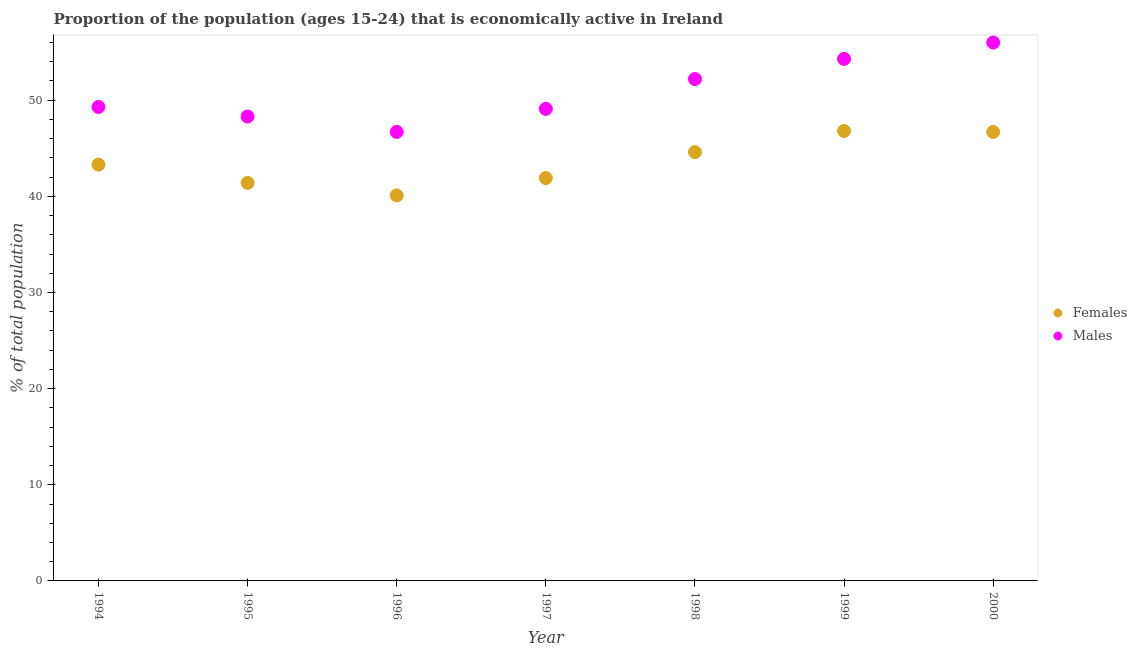How many different coloured dotlines are there?
Offer a very short reply. 2. What is the percentage of economically active female population in 2000?
Make the answer very short. 46.7. Across all years, what is the maximum percentage of economically active female population?
Offer a very short reply. 46.8. Across all years, what is the minimum percentage of economically active female population?
Offer a very short reply. 40.1. What is the total percentage of economically active female population in the graph?
Give a very brief answer. 304.8. What is the difference between the percentage of economically active male population in 1998 and the percentage of economically active female population in 1995?
Ensure brevity in your answer.  10.8. What is the average percentage of economically active male population per year?
Keep it short and to the point. 50.84. In the year 1995, what is the difference between the percentage of economically active female population and percentage of economically active male population?
Your answer should be very brief. -6.9. What is the ratio of the percentage of economically active male population in 1994 to that in 1996?
Your answer should be very brief. 1.06. What is the difference between the highest and the second highest percentage of economically active female population?
Ensure brevity in your answer.  0.1. What is the difference between the highest and the lowest percentage of economically active male population?
Give a very brief answer. 9.3. Does the percentage of economically active male population monotonically increase over the years?
Your answer should be compact. No. Is the percentage of economically active male population strictly greater than the percentage of economically active female population over the years?
Provide a short and direct response. Yes. How many dotlines are there?
Provide a succinct answer. 2. Does the graph contain any zero values?
Provide a succinct answer. No. Does the graph contain grids?
Keep it short and to the point. No. Where does the legend appear in the graph?
Keep it short and to the point. Center right. How many legend labels are there?
Provide a short and direct response. 2. How are the legend labels stacked?
Offer a very short reply. Vertical. What is the title of the graph?
Your response must be concise. Proportion of the population (ages 15-24) that is economically active in Ireland. Does "Domestic Liabilities" appear as one of the legend labels in the graph?
Keep it short and to the point. No. What is the label or title of the Y-axis?
Provide a succinct answer. % of total population. What is the % of total population in Females in 1994?
Keep it short and to the point. 43.3. What is the % of total population in Males in 1994?
Ensure brevity in your answer.  49.3. What is the % of total population in Females in 1995?
Offer a terse response. 41.4. What is the % of total population in Males in 1995?
Offer a very short reply. 48.3. What is the % of total population of Females in 1996?
Your response must be concise. 40.1. What is the % of total population in Males in 1996?
Your response must be concise. 46.7. What is the % of total population in Females in 1997?
Make the answer very short. 41.9. What is the % of total population of Males in 1997?
Ensure brevity in your answer.  49.1. What is the % of total population of Females in 1998?
Your response must be concise. 44.6. What is the % of total population of Males in 1998?
Ensure brevity in your answer.  52.2. What is the % of total population of Females in 1999?
Offer a very short reply. 46.8. What is the % of total population in Males in 1999?
Your answer should be compact. 54.3. What is the % of total population of Females in 2000?
Offer a very short reply. 46.7. What is the % of total population in Males in 2000?
Your answer should be compact. 56. Across all years, what is the maximum % of total population in Females?
Your response must be concise. 46.8. Across all years, what is the maximum % of total population of Males?
Make the answer very short. 56. Across all years, what is the minimum % of total population of Females?
Give a very brief answer. 40.1. Across all years, what is the minimum % of total population of Males?
Offer a terse response. 46.7. What is the total % of total population in Females in the graph?
Offer a terse response. 304.8. What is the total % of total population in Males in the graph?
Offer a very short reply. 355.9. What is the difference between the % of total population in Females in 1994 and that in 1996?
Offer a terse response. 3.2. What is the difference between the % of total population in Males in 1994 and that in 1996?
Make the answer very short. 2.6. What is the difference between the % of total population of Females in 1994 and that in 1999?
Keep it short and to the point. -3.5. What is the difference between the % of total population in Males in 1994 and that in 1999?
Your answer should be compact. -5. What is the difference between the % of total population in Females in 1994 and that in 2000?
Offer a terse response. -3.4. What is the difference between the % of total population in Females in 1995 and that in 1997?
Offer a terse response. -0.5. What is the difference between the % of total population of Males in 1995 and that in 1997?
Your answer should be very brief. -0.8. What is the difference between the % of total population in Females in 1995 and that in 1998?
Your answer should be compact. -3.2. What is the difference between the % of total population of Males in 1995 and that in 1998?
Make the answer very short. -3.9. What is the difference between the % of total population in Females in 1996 and that in 1999?
Your answer should be very brief. -6.7. What is the difference between the % of total population in Males in 1996 and that in 1999?
Make the answer very short. -7.6. What is the difference between the % of total population in Males in 1996 and that in 2000?
Your answer should be very brief. -9.3. What is the difference between the % of total population of Females in 1997 and that in 1999?
Give a very brief answer. -4.9. What is the difference between the % of total population in Females in 1997 and that in 2000?
Make the answer very short. -4.8. What is the difference between the % of total population in Males in 1997 and that in 2000?
Your response must be concise. -6.9. What is the difference between the % of total population of Males in 1998 and that in 2000?
Offer a very short reply. -3.8. What is the difference between the % of total population in Females in 1994 and the % of total population in Males in 1997?
Your answer should be very brief. -5.8. What is the difference between the % of total population in Females in 1994 and the % of total population in Males in 1998?
Offer a very short reply. -8.9. What is the difference between the % of total population of Females in 1995 and the % of total population of Males in 1998?
Your answer should be very brief. -10.8. What is the difference between the % of total population in Females in 1995 and the % of total population in Males in 1999?
Offer a terse response. -12.9. What is the difference between the % of total population of Females in 1995 and the % of total population of Males in 2000?
Ensure brevity in your answer.  -14.6. What is the difference between the % of total population of Females in 1996 and the % of total population of Males in 1999?
Provide a short and direct response. -14.2. What is the difference between the % of total population of Females in 1996 and the % of total population of Males in 2000?
Give a very brief answer. -15.9. What is the difference between the % of total population of Females in 1997 and the % of total population of Males in 2000?
Your answer should be very brief. -14.1. What is the difference between the % of total population in Females in 1998 and the % of total population in Males in 2000?
Give a very brief answer. -11.4. What is the difference between the % of total population of Females in 1999 and the % of total population of Males in 2000?
Offer a very short reply. -9.2. What is the average % of total population in Females per year?
Keep it short and to the point. 43.54. What is the average % of total population of Males per year?
Your answer should be very brief. 50.84. In the year 1996, what is the difference between the % of total population of Females and % of total population of Males?
Keep it short and to the point. -6.6. In the year 1997, what is the difference between the % of total population in Females and % of total population in Males?
Provide a succinct answer. -7.2. In the year 1998, what is the difference between the % of total population in Females and % of total population in Males?
Keep it short and to the point. -7.6. In the year 1999, what is the difference between the % of total population of Females and % of total population of Males?
Make the answer very short. -7.5. In the year 2000, what is the difference between the % of total population of Females and % of total population of Males?
Your answer should be compact. -9.3. What is the ratio of the % of total population in Females in 1994 to that in 1995?
Offer a terse response. 1.05. What is the ratio of the % of total population in Males in 1994 to that in 1995?
Ensure brevity in your answer.  1.02. What is the ratio of the % of total population of Females in 1994 to that in 1996?
Keep it short and to the point. 1.08. What is the ratio of the % of total population of Males in 1994 to that in 1996?
Your answer should be compact. 1.06. What is the ratio of the % of total population in Females in 1994 to that in 1997?
Provide a succinct answer. 1.03. What is the ratio of the % of total population of Females in 1994 to that in 1998?
Your answer should be compact. 0.97. What is the ratio of the % of total population of Males in 1994 to that in 1998?
Offer a terse response. 0.94. What is the ratio of the % of total population in Females in 1994 to that in 1999?
Offer a very short reply. 0.93. What is the ratio of the % of total population in Males in 1994 to that in 1999?
Give a very brief answer. 0.91. What is the ratio of the % of total population of Females in 1994 to that in 2000?
Make the answer very short. 0.93. What is the ratio of the % of total population in Males in 1994 to that in 2000?
Offer a very short reply. 0.88. What is the ratio of the % of total population of Females in 1995 to that in 1996?
Keep it short and to the point. 1.03. What is the ratio of the % of total population in Males in 1995 to that in 1996?
Your answer should be compact. 1.03. What is the ratio of the % of total population in Males in 1995 to that in 1997?
Make the answer very short. 0.98. What is the ratio of the % of total population in Females in 1995 to that in 1998?
Ensure brevity in your answer.  0.93. What is the ratio of the % of total population of Males in 1995 to that in 1998?
Offer a very short reply. 0.93. What is the ratio of the % of total population of Females in 1995 to that in 1999?
Your answer should be compact. 0.88. What is the ratio of the % of total population in Males in 1995 to that in 1999?
Offer a very short reply. 0.89. What is the ratio of the % of total population in Females in 1995 to that in 2000?
Offer a terse response. 0.89. What is the ratio of the % of total population in Males in 1995 to that in 2000?
Provide a succinct answer. 0.86. What is the ratio of the % of total population of Females in 1996 to that in 1997?
Keep it short and to the point. 0.96. What is the ratio of the % of total population in Males in 1996 to that in 1997?
Offer a terse response. 0.95. What is the ratio of the % of total population of Females in 1996 to that in 1998?
Make the answer very short. 0.9. What is the ratio of the % of total population in Males in 1996 to that in 1998?
Your answer should be compact. 0.89. What is the ratio of the % of total population in Females in 1996 to that in 1999?
Your response must be concise. 0.86. What is the ratio of the % of total population of Males in 1996 to that in 1999?
Your answer should be compact. 0.86. What is the ratio of the % of total population of Females in 1996 to that in 2000?
Offer a very short reply. 0.86. What is the ratio of the % of total population in Males in 1996 to that in 2000?
Give a very brief answer. 0.83. What is the ratio of the % of total population in Females in 1997 to that in 1998?
Provide a succinct answer. 0.94. What is the ratio of the % of total population of Males in 1997 to that in 1998?
Your answer should be compact. 0.94. What is the ratio of the % of total population of Females in 1997 to that in 1999?
Keep it short and to the point. 0.9. What is the ratio of the % of total population of Males in 1997 to that in 1999?
Provide a succinct answer. 0.9. What is the ratio of the % of total population in Females in 1997 to that in 2000?
Provide a succinct answer. 0.9. What is the ratio of the % of total population of Males in 1997 to that in 2000?
Provide a succinct answer. 0.88. What is the ratio of the % of total population of Females in 1998 to that in 1999?
Make the answer very short. 0.95. What is the ratio of the % of total population in Males in 1998 to that in 1999?
Your answer should be very brief. 0.96. What is the ratio of the % of total population in Females in 1998 to that in 2000?
Provide a succinct answer. 0.95. What is the ratio of the % of total population of Males in 1998 to that in 2000?
Your answer should be very brief. 0.93. What is the ratio of the % of total population of Males in 1999 to that in 2000?
Keep it short and to the point. 0.97. What is the difference between the highest and the second highest % of total population in Females?
Offer a terse response. 0.1. What is the difference between the highest and the lowest % of total population of Females?
Give a very brief answer. 6.7. 